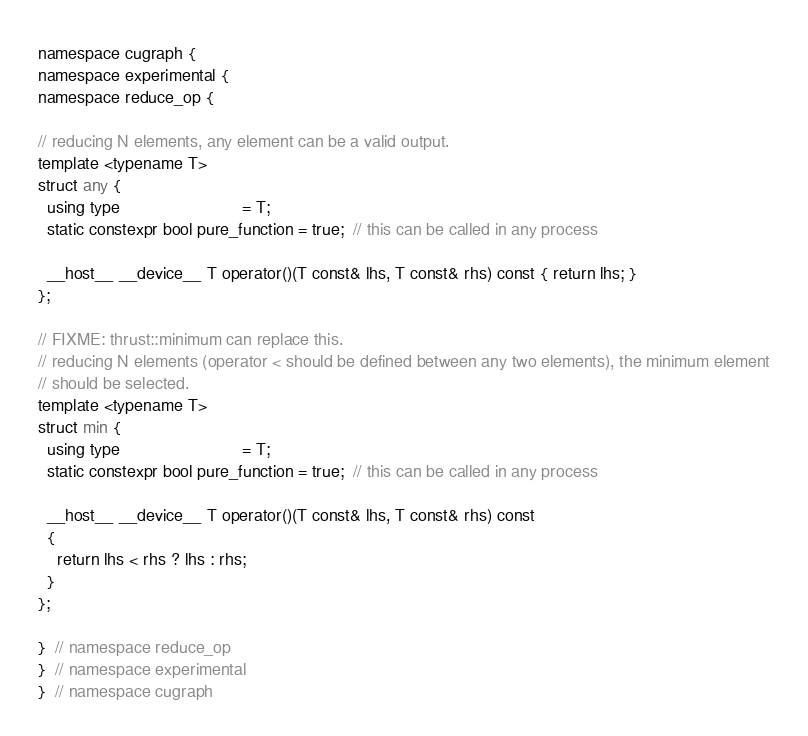Convert code to text. <code><loc_0><loc_0><loc_500><loc_500><_Cuda_>
namespace cugraph {
namespace experimental {
namespace reduce_op {

// reducing N elements, any element can be a valid output.
template <typename T>
struct any {
  using type                          = T;
  static constexpr bool pure_function = true;  // this can be called in any process

  __host__ __device__ T operator()(T const& lhs, T const& rhs) const { return lhs; }
};

// FIXME: thrust::minimum can replace this.
// reducing N elements (operator < should be defined between any two elements), the minimum element
// should be selected.
template <typename T>
struct min {
  using type                          = T;
  static constexpr bool pure_function = true;  // this can be called in any process

  __host__ __device__ T operator()(T const& lhs, T const& rhs) const
  {
    return lhs < rhs ? lhs : rhs;
  }
};

}  // namespace reduce_op
}  // namespace experimental
}  // namespace cugraph
</code> 